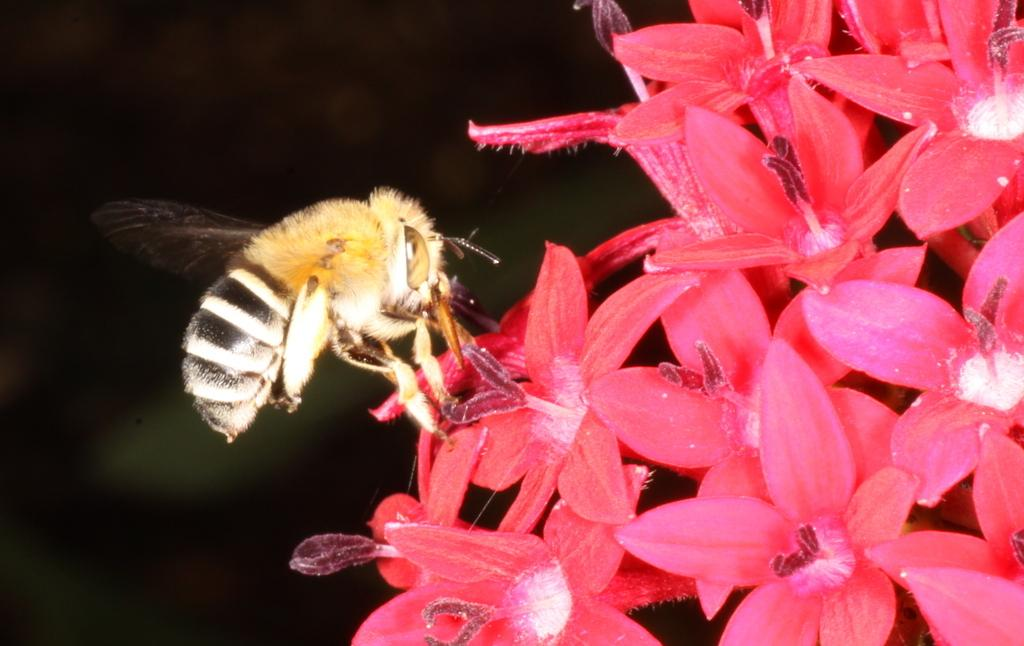What type of insect is present in the image? There is a honey bee in the image. What is the honey bee interacting with in the image? The honey bee is interacting with flowers in the image. What can be observed about the overall lighting in the image? The background of the image is dark. What scene is the honey bee's friend trying to stop in the image? There is no scene or friend present in the image; it only features a honey bee and flowers. 